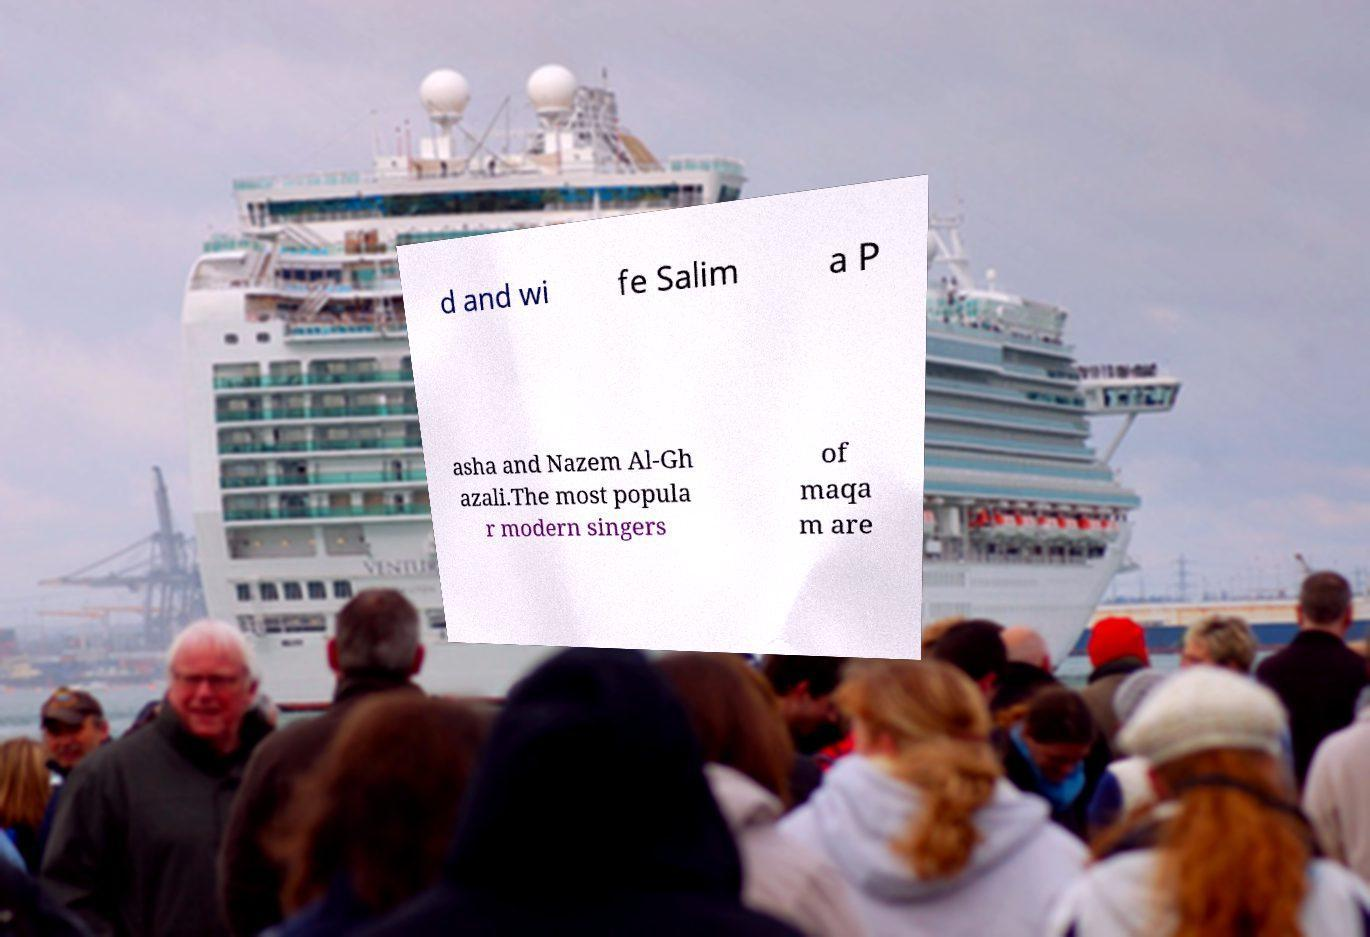Can you accurately transcribe the text from the provided image for me? d and wi fe Salim a P asha and Nazem Al-Gh azali.The most popula r modern singers of maqa m are 